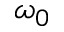Convert formula to latex. <formula><loc_0><loc_0><loc_500><loc_500>\omega _ { 0 }</formula> 